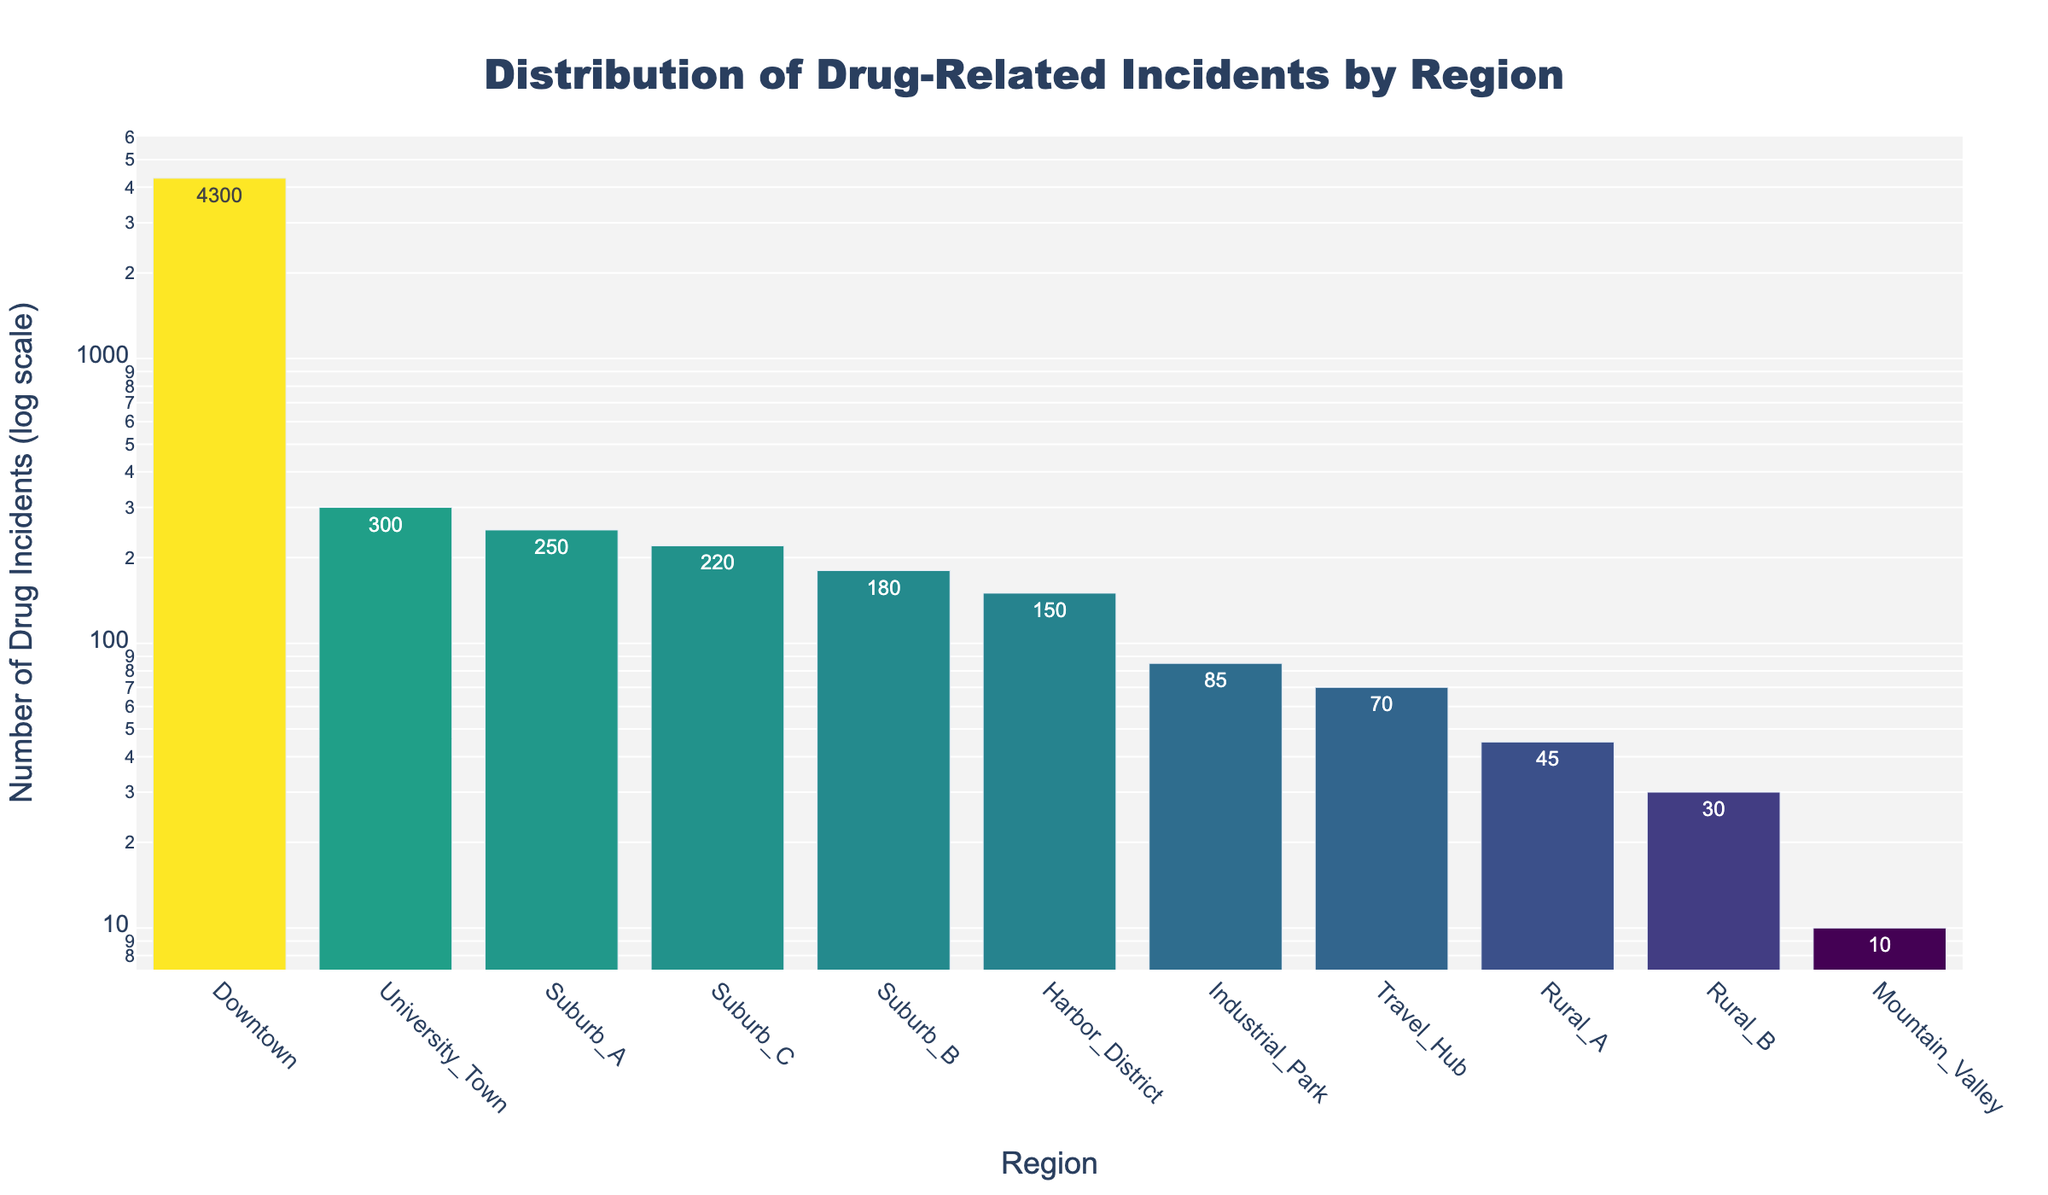What is the title of the plot? Look at the top of the plot where the title is displayed in large, bold letters.
Answer: Distribution of Drug-Related Incidents by Region How many regions are displayed in the plot? Count the number of bars or region labels along the x-axis.
Answer: 11 Which region has the highest number of drug-related incidents? Find the bar with the greatest height or the highest y-axis value.
Answer: Downtown What is the approximate number of drug-related incidents in Industrial Park? Look at the bar corresponding to Industrial Park and check the labeled value or height of the bar on the y-axis.
Answer: 85 By what factor does the number of drug-related incidents in Downtown exceed that in University Town? Divide the number of incidents in Downtown (4300) by the number of incidents in University Town (300) to find the ratio.
Answer: ≈14.33 What is the total number of drug-related incidents in all the suburban areas (Suburb A, Suburb B, and Suburb C)? Sum the values of Suburb A (250), Suburb B (180), and Suburb C (220).
Answer: 650 Which region has the lowest number of drug-related incidents? Find the bar with the smallest height or the lowest y-axis value.
Answer: Mountain Valley How does the number of drug-related incidents in Harbor District compare to Travel Hub? Compare the values of the bars for Harbor District (150) and Travel Hub (70).
Answer: Harbor District has more incidents What is the average number of drug-related incidents for all rural regions (Rural A and Rural B)? Sum the values of Rural A (45) and Rural B (30), then divide by 2.
Answer: 37.5 Identify the range of the number of drug incidents on the y-axis where the color transition is most noticeable. Look for the section of the bar colors that shifts notably due to the log scale effect and its color gradient.
Answer: Between 10 and 100 